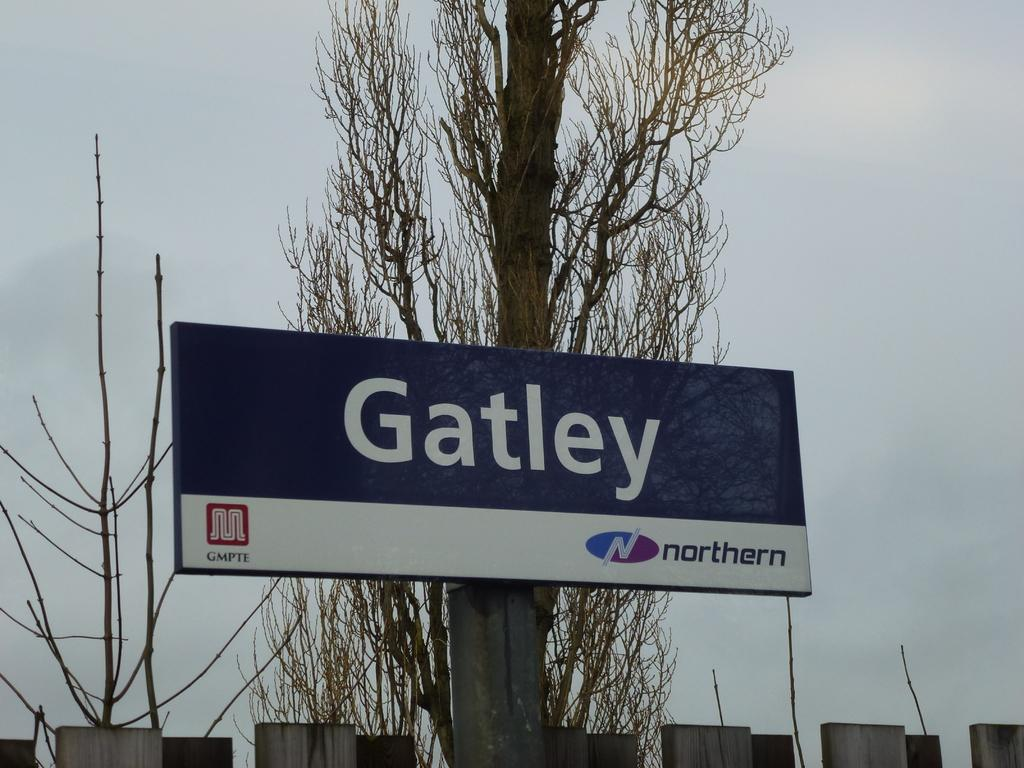What is the main object in the center of the image? There is a name board in the center of the image. How is the name board positioned in the image? The name board is attached to a tree. What can be seen in the background of the image? Sky is visible in the background of the image. What is the condition of the sky in the image? Clouds are present in the sky. Can you see a rat hiding behind the name board in the image? There is no rat present in the image. Is there a picture of a jail on the name board in the image? The image does not show any pictures or text on the name board, so it cannot be determined if there is a picture of a jail. 